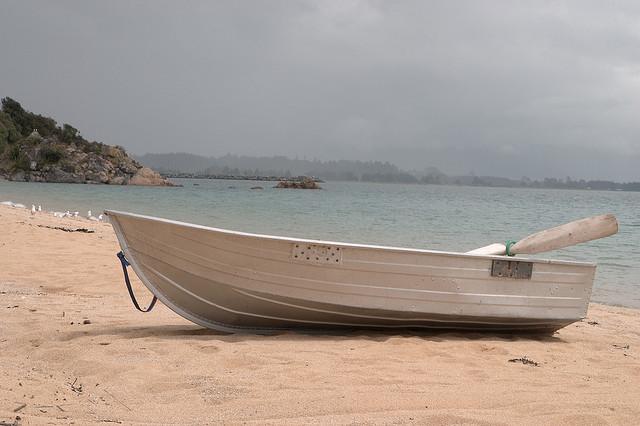Where is this boat at?
Write a very short answer. Beach. Is this a yacht?
Give a very brief answer. No. How many boats are pictured?
Write a very short answer. 1. Would you be protected from a sudden downpour if you hid in this boat?
Quick response, please. No. Which boat has an engine?
Short answer required. None. Where are the people?
Give a very brief answer. Home. 